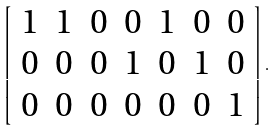<formula> <loc_0><loc_0><loc_500><loc_500>\left [ \begin{array} { c c c c c c c } 1 & 1 & 0 & 0 & 1 & 0 & 0 \\ 0 & 0 & 0 & 1 & 0 & 1 & 0 \\ 0 & 0 & 0 & 0 & 0 & 0 & 1 \end{array} \right ] .</formula> 